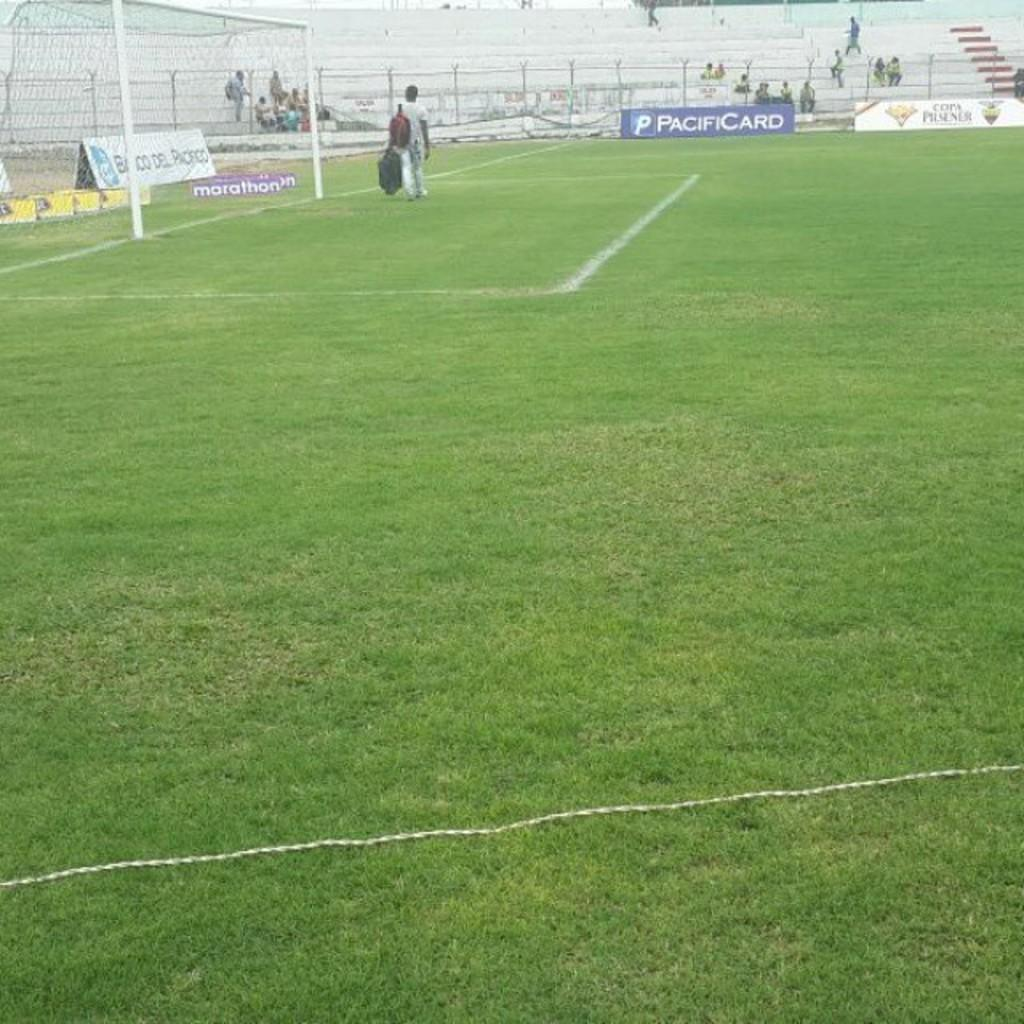<image>
Write a terse but informative summary of the picture. A soccer field with a Pacificard sign on it. 